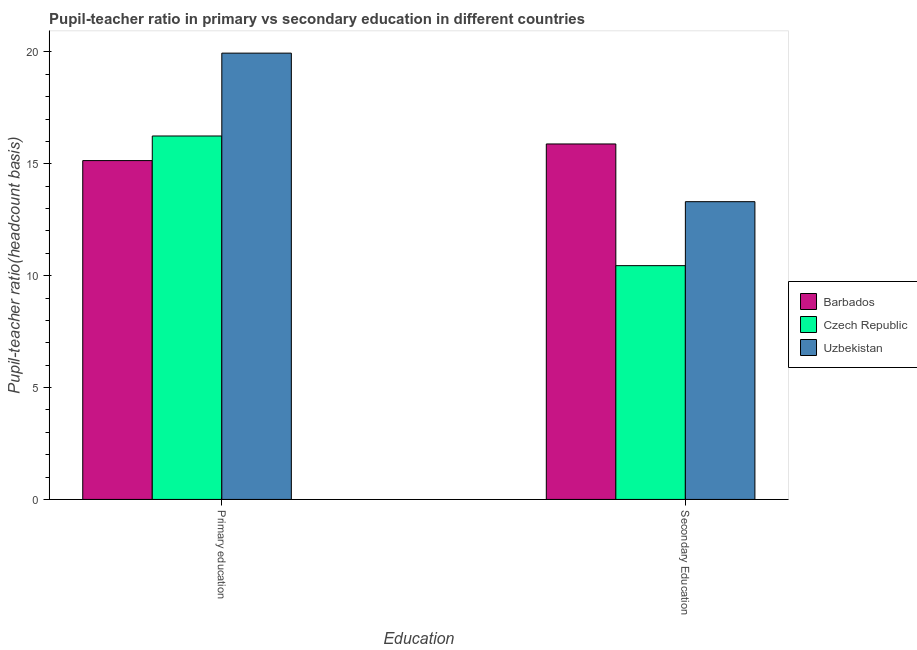How many different coloured bars are there?
Give a very brief answer. 3. How many groups of bars are there?
Your answer should be very brief. 2. Are the number of bars per tick equal to the number of legend labels?
Provide a short and direct response. Yes. What is the label of the 2nd group of bars from the left?
Give a very brief answer. Secondary Education. What is the pupil teacher ratio on secondary education in Czech Republic?
Provide a short and direct response. 10.45. Across all countries, what is the maximum pupil-teacher ratio in primary education?
Offer a very short reply. 19.95. Across all countries, what is the minimum pupil teacher ratio on secondary education?
Your response must be concise. 10.45. In which country was the pupil-teacher ratio in primary education maximum?
Your response must be concise. Uzbekistan. In which country was the pupil teacher ratio on secondary education minimum?
Your answer should be compact. Czech Republic. What is the total pupil-teacher ratio in primary education in the graph?
Your answer should be very brief. 51.34. What is the difference between the pupil-teacher ratio in primary education in Czech Republic and that in Barbados?
Your response must be concise. 1.1. What is the difference between the pupil teacher ratio on secondary education in Barbados and the pupil-teacher ratio in primary education in Uzbekistan?
Offer a terse response. -4.06. What is the average pupil teacher ratio on secondary education per country?
Your answer should be very brief. 13.22. What is the difference between the pupil teacher ratio on secondary education and pupil-teacher ratio in primary education in Barbados?
Your answer should be very brief. 0.74. What is the ratio of the pupil-teacher ratio in primary education in Czech Republic to that in Barbados?
Provide a succinct answer. 1.07. What does the 3rd bar from the left in Secondary Education represents?
Give a very brief answer. Uzbekistan. What does the 3rd bar from the right in Secondary Education represents?
Offer a terse response. Barbados. Are all the bars in the graph horizontal?
Offer a very short reply. No. How many countries are there in the graph?
Your answer should be compact. 3. Are the values on the major ticks of Y-axis written in scientific E-notation?
Your answer should be very brief. No. Does the graph contain grids?
Offer a terse response. No. How many legend labels are there?
Give a very brief answer. 3. What is the title of the graph?
Provide a short and direct response. Pupil-teacher ratio in primary vs secondary education in different countries. What is the label or title of the X-axis?
Give a very brief answer. Education. What is the label or title of the Y-axis?
Your answer should be compact. Pupil-teacher ratio(headcount basis). What is the Pupil-teacher ratio(headcount basis) in Barbados in Primary education?
Keep it short and to the point. 15.15. What is the Pupil-teacher ratio(headcount basis) in Czech Republic in Primary education?
Your answer should be very brief. 16.25. What is the Pupil-teacher ratio(headcount basis) in Uzbekistan in Primary education?
Offer a very short reply. 19.95. What is the Pupil-teacher ratio(headcount basis) of Barbados in Secondary Education?
Your answer should be very brief. 15.89. What is the Pupil-teacher ratio(headcount basis) of Czech Republic in Secondary Education?
Provide a succinct answer. 10.45. What is the Pupil-teacher ratio(headcount basis) of Uzbekistan in Secondary Education?
Your answer should be very brief. 13.31. Across all Education, what is the maximum Pupil-teacher ratio(headcount basis) of Barbados?
Offer a very short reply. 15.89. Across all Education, what is the maximum Pupil-teacher ratio(headcount basis) in Czech Republic?
Offer a terse response. 16.25. Across all Education, what is the maximum Pupil-teacher ratio(headcount basis) of Uzbekistan?
Your response must be concise. 19.95. Across all Education, what is the minimum Pupil-teacher ratio(headcount basis) in Barbados?
Your answer should be very brief. 15.15. Across all Education, what is the minimum Pupil-teacher ratio(headcount basis) in Czech Republic?
Provide a short and direct response. 10.45. Across all Education, what is the minimum Pupil-teacher ratio(headcount basis) of Uzbekistan?
Give a very brief answer. 13.31. What is the total Pupil-teacher ratio(headcount basis) in Barbados in the graph?
Provide a succinct answer. 31.03. What is the total Pupil-teacher ratio(headcount basis) in Czech Republic in the graph?
Provide a short and direct response. 26.7. What is the total Pupil-teacher ratio(headcount basis) in Uzbekistan in the graph?
Your answer should be very brief. 33.26. What is the difference between the Pupil-teacher ratio(headcount basis) in Barbados in Primary education and that in Secondary Education?
Give a very brief answer. -0.74. What is the difference between the Pupil-teacher ratio(headcount basis) of Czech Republic in Primary education and that in Secondary Education?
Offer a very short reply. 5.8. What is the difference between the Pupil-teacher ratio(headcount basis) of Uzbekistan in Primary education and that in Secondary Education?
Make the answer very short. 6.64. What is the difference between the Pupil-teacher ratio(headcount basis) of Barbados in Primary education and the Pupil-teacher ratio(headcount basis) of Czech Republic in Secondary Education?
Your response must be concise. 4.7. What is the difference between the Pupil-teacher ratio(headcount basis) of Barbados in Primary education and the Pupil-teacher ratio(headcount basis) of Uzbekistan in Secondary Education?
Keep it short and to the point. 1.84. What is the difference between the Pupil-teacher ratio(headcount basis) of Czech Republic in Primary education and the Pupil-teacher ratio(headcount basis) of Uzbekistan in Secondary Education?
Your response must be concise. 2.94. What is the average Pupil-teacher ratio(headcount basis) in Barbados per Education?
Ensure brevity in your answer.  15.52. What is the average Pupil-teacher ratio(headcount basis) of Czech Republic per Education?
Your answer should be compact. 13.35. What is the average Pupil-teacher ratio(headcount basis) in Uzbekistan per Education?
Give a very brief answer. 16.63. What is the difference between the Pupil-teacher ratio(headcount basis) in Barbados and Pupil-teacher ratio(headcount basis) in Czech Republic in Primary education?
Make the answer very short. -1.1. What is the difference between the Pupil-teacher ratio(headcount basis) in Barbados and Pupil-teacher ratio(headcount basis) in Uzbekistan in Primary education?
Keep it short and to the point. -4.8. What is the difference between the Pupil-teacher ratio(headcount basis) of Czech Republic and Pupil-teacher ratio(headcount basis) of Uzbekistan in Primary education?
Provide a short and direct response. -3.7. What is the difference between the Pupil-teacher ratio(headcount basis) of Barbados and Pupil-teacher ratio(headcount basis) of Czech Republic in Secondary Education?
Give a very brief answer. 5.44. What is the difference between the Pupil-teacher ratio(headcount basis) in Barbados and Pupil-teacher ratio(headcount basis) in Uzbekistan in Secondary Education?
Provide a succinct answer. 2.58. What is the difference between the Pupil-teacher ratio(headcount basis) of Czech Republic and Pupil-teacher ratio(headcount basis) of Uzbekistan in Secondary Education?
Your answer should be very brief. -2.86. What is the ratio of the Pupil-teacher ratio(headcount basis) of Barbados in Primary education to that in Secondary Education?
Offer a very short reply. 0.95. What is the ratio of the Pupil-teacher ratio(headcount basis) in Czech Republic in Primary education to that in Secondary Education?
Offer a terse response. 1.55. What is the ratio of the Pupil-teacher ratio(headcount basis) of Uzbekistan in Primary education to that in Secondary Education?
Ensure brevity in your answer.  1.5. What is the difference between the highest and the second highest Pupil-teacher ratio(headcount basis) of Barbados?
Keep it short and to the point. 0.74. What is the difference between the highest and the second highest Pupil-teacher ratio(headcount basis) of Czech Republic?
Provide a succinct answer. 5.8. What is the difference between the highest and the second highest Pupil-teacher ratio(headcount basis) of Uzbekistan?
Your response must be concise. 6.64. What is the difference between the highest and the lowest Pupil-teacher ratio(headcount basis) of Barbados?
Keep it short and to the point. 0.74. What is the difference between the highest and the lowest Pupil-teacher ratio(headcount basis) in Czech Republic?
Offer a terse response. 5.8. What is the difference between the highest and the lowest Pupil-teacher ratio(headcount basis) of Uzbekistan?
Your answer should be very brief. 6.64. 